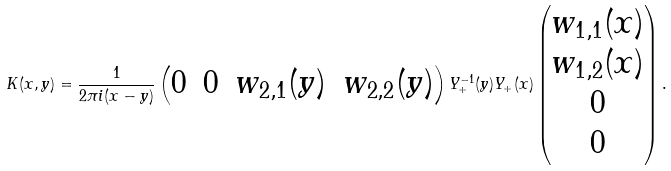Convert formula to latex. <formula><loc_0><loc_0><loc_500><loc_500>K ( x , y ) = \frac { 1 } { 2 \pi i ( x - y ) } \begin{pmatrix} 0 & 0 & w _ { 2 , 1 } ( y ) & w _ { 2 , 2 } ( y ) \end{pmatrix} Y _ { + } ^ { - 1 } ( y ) Y _ { + } ( x ) \begin{pmatrix} w _ { 1 , 1 } ( x ) \\ w _ { 1 , 2 } ( x ) \\ 0 \\ 0 \end{pmatrix} .</formula> 